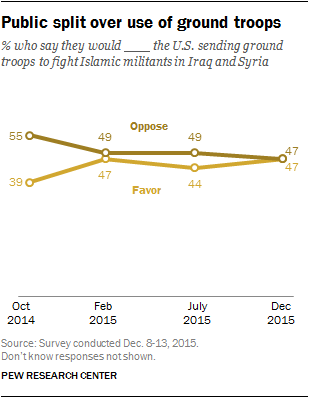Highlight a few significant elements in this photo. The value of Favor Graph was 47 in December 2015 and it was true at that time. The median value of the "Oppose" graph is 49%, indicating that half of the tweets in this graph oppose the proposed legislation and half support it. 